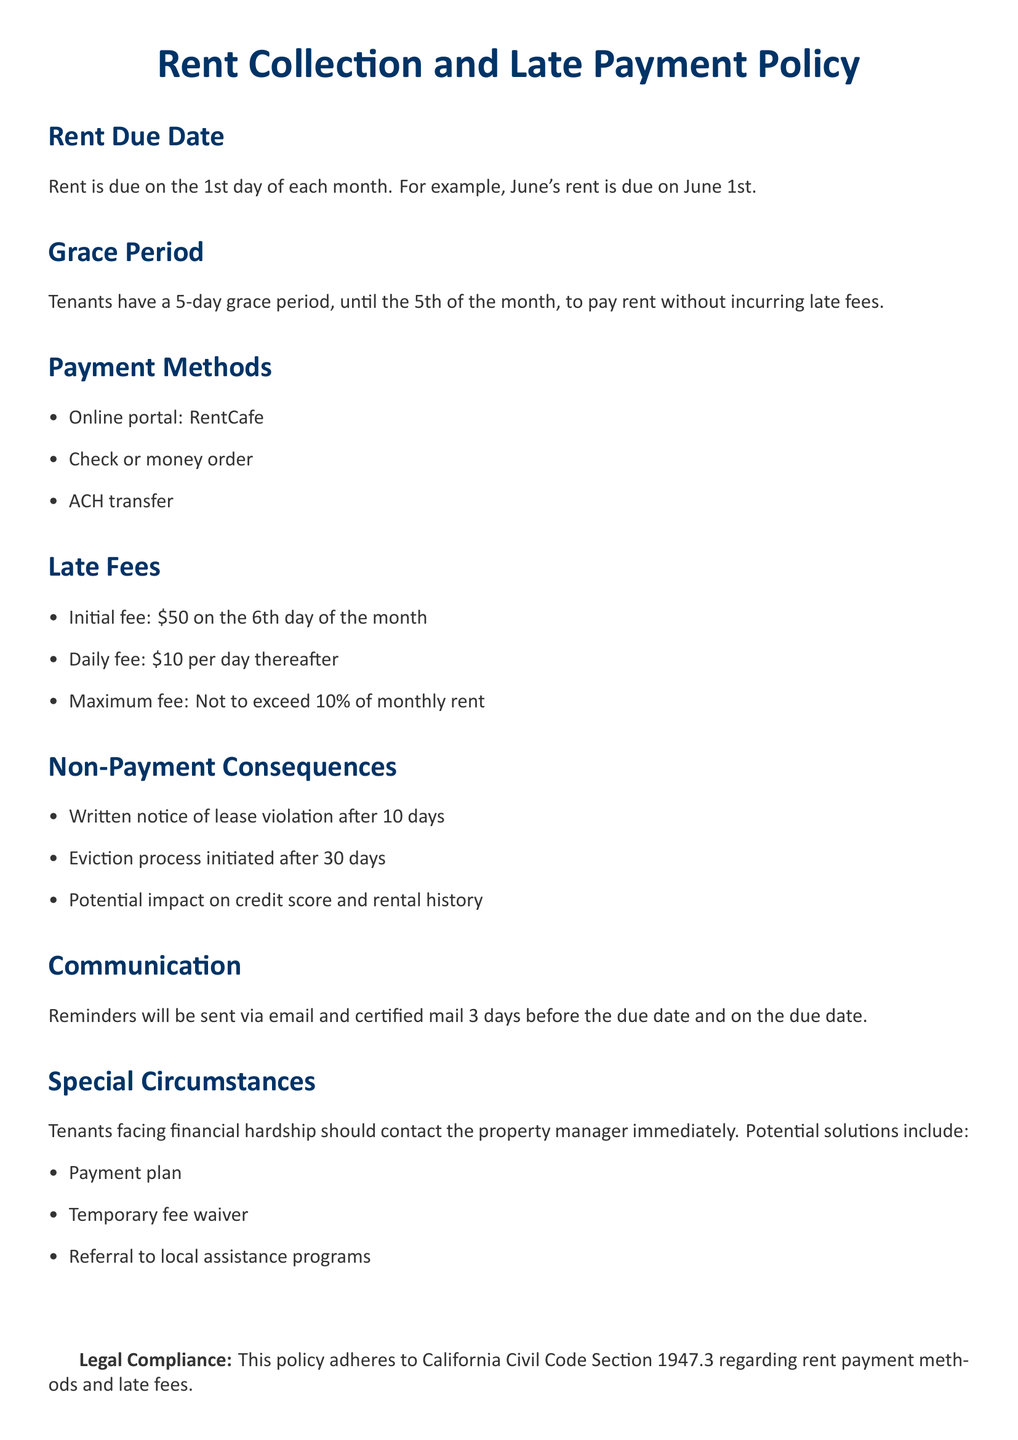What is the rent due date? The rent is due on the 1st day of each month as stated in the policy.
Answer: 1st What is the grace period for rent payment? The document specifies that tenants have a 5-day grace period to pay rent without fees.
Answer: 5 days What is the initial late fee imposed? The document mentions an initial late fee charged on the 6th day of the month.
Answer: $50 What is the daily late fee after the initial fee? The policy details that there is a daily fee that continues accumulating after the initial late fee.
Answer: $10 What action is taken after 10 days of non-payment? The policy outlines that a written notice of lease violation is sent after 10 days of non-payment.
Answer: Written notice What maximum late fee percentage is allowed? The document clearly states that the maximum late fee should not exceed a specific percentage of the monthly rent.
Answer: 10% How are rent reminders communicated to tenants? The communication method for sending rent reminders is specified in the policy.
Answer: Email and certified mail What should tenants do if they face financial hardship? The policy encourages tenants in financial distress to take a specific action for guidance and support.
Answer: Contact the property manager What is initiated after 30 days of non-payment? The document states that a particular process begins if rent remains unpaid after 30 days.
Answer: Eviction process 